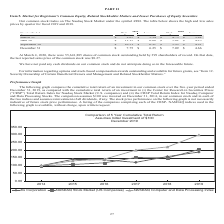From Zix Corporation's financial document, What was the high and low value for ZIXI for the quarter ended March 31 2019? The document shows two values: 9.07 and 5.34. From the document: "March 31 $ 9.07 $ 5.34 $ 4.75 $ 3.82 March 31 $ 9.07 $ 5.34 $ 4.75 $ 3.82..." Also, How many shares of common stock are there outstanding as at March 4, 2020? According to the financial document, 55,641,885. The relevant text states: "At March 4, 2020, there were 55,641,885 shares of common stock outstanding held by 399 shareholders of record. On that date, the last repor..." Also, Where can one find information on options and stock-based compensation awards outstanding and available for future grants? Item 12. Security Ownership of Certain Beneficial Owners and Management and Related Stockholder Matters.. The document states: "outstanding and available for future grants, see “Item 12. Security Ownership of Certain Beneficial Owners and Management and Related Stockholder Matt..." Also, can you calculate: What is the average number of shares of common stock outstanding held by each shareholder as of March 4 2020? Based on the calculation: 55,641,885/399, the result is 139453.35. This is based on the information: "At March 4, 2020, there were 55,641,885 shares of common stock outstanding held by 399 shareholders of record. On that date, the last repor 41,885 shares of common stock outstanding held by 399 shareh..." The key data points involved are: 399, 55,641,885. Also, can you calculate: What is the average low sale prices for the year 2019? To answer this question, I need to perform calculations using the financial data. The calculation is: (5.34+6.66+6.91+6.25)/4, which equals 6.29. This is based on the information: "December 31 $ 7.75 $ 6.25 $ 7.09 $ 4.66 June 30 $ 11.15 $ 6.66 $ 5.62 $ 4.25 September 30 $ 10.51 $ 6.91 $ 5.93 $ 4.91 March 31 $ 9.07 $ 5.34 $ 4.75 $ 3.82..." The key data points involved are: 5.34, 6.25, 6.66. Also, can you calculate: What was the change in high value for the quarter ended september 30 in 2019 than 2018? Based on the calculation: 10.51-5.93, the result is 4.58. This is based on the information: "September 30 $ 10.51 $ 6.91 $ 5.93 $ 4.91 September 30 $ 10.51 $ 6.91 $ 5.93 $ 4.91..." The key data points involved are: 10.51, 5.93. 